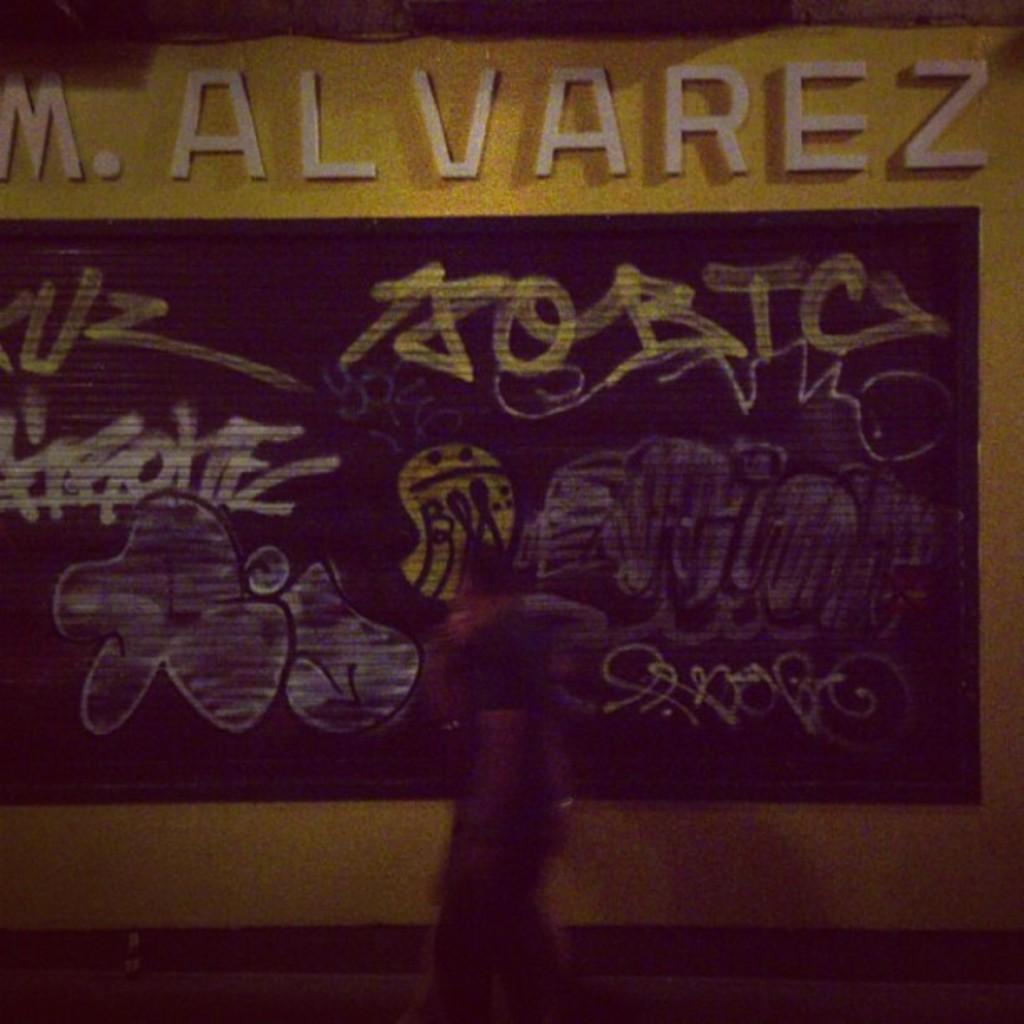Please provide a concise description of this image. This image consists of a person walking. In the background, we can see a poster on the wall. And we can see the text. 